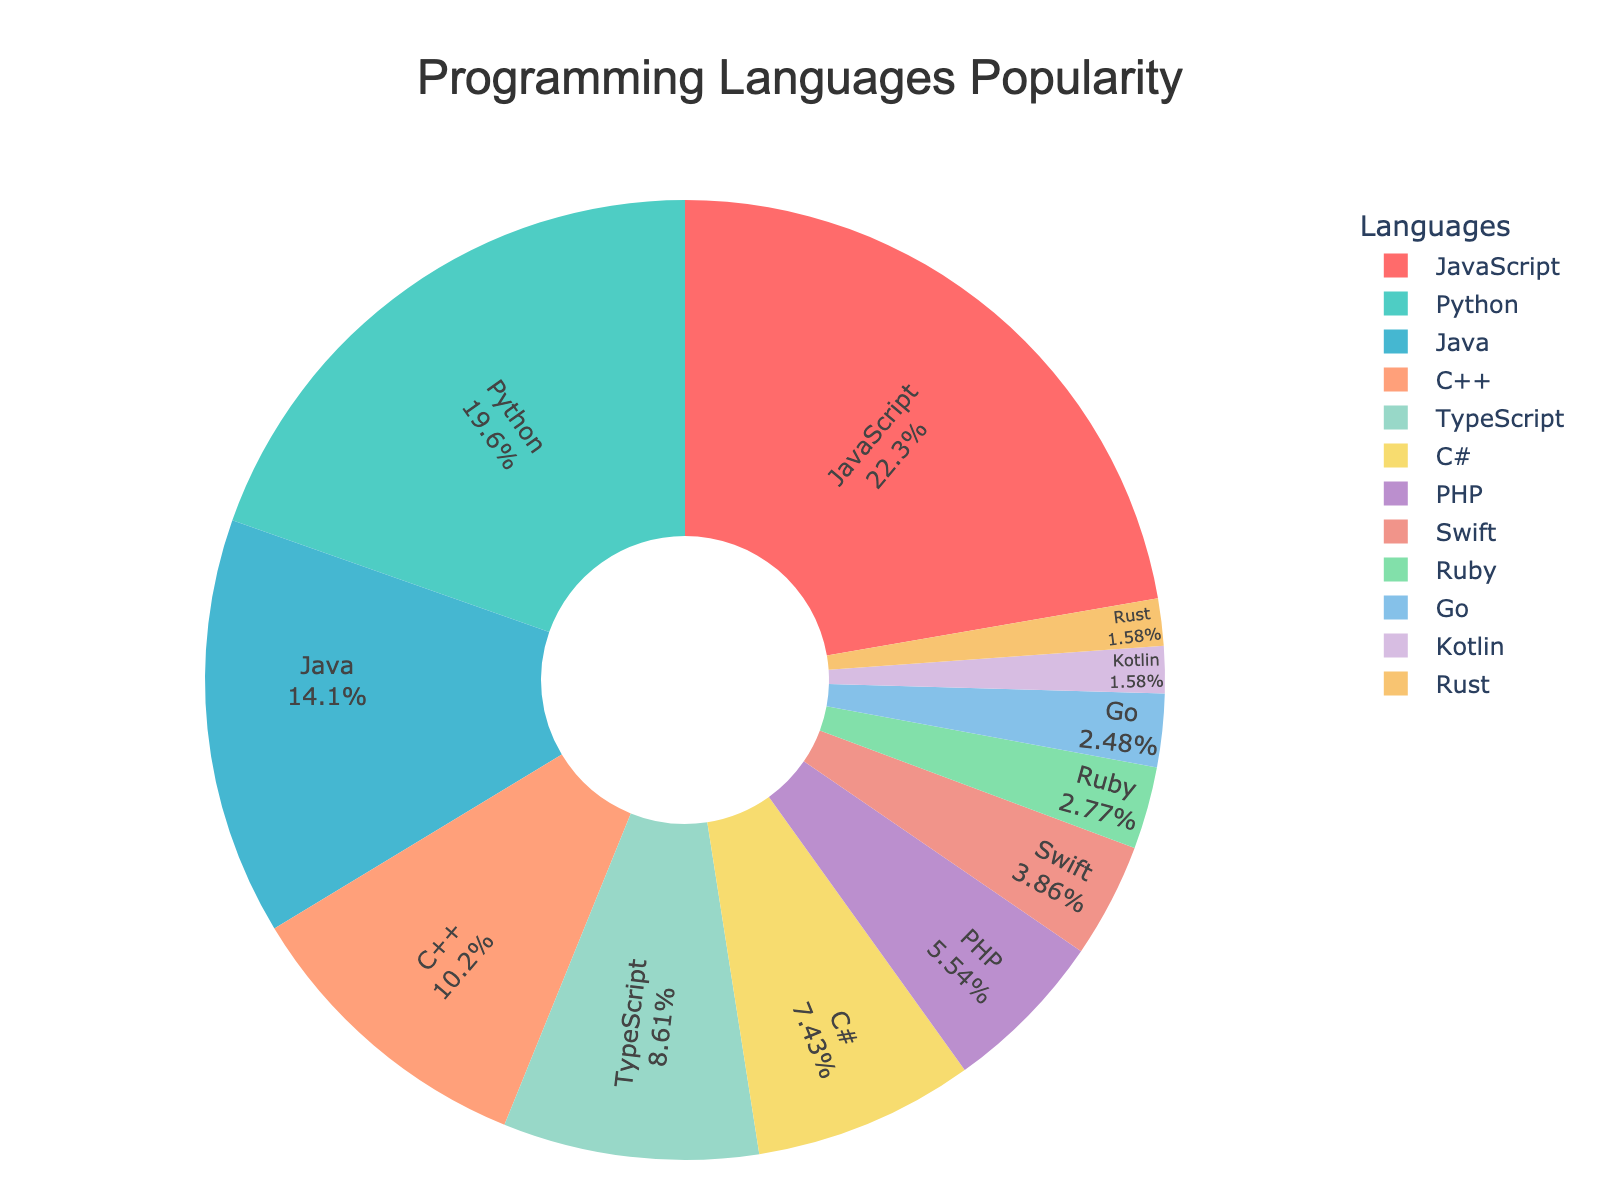What percentage of developers use JavaScript? Look at the segment labeled JavaScript and read the corresponding percentage.
Answer: 22.5% Which programming language is the second most popular? Identify and compare the percentages of the segments. The second highest value is 19.8%, which corresponds to Python.
Answer: Python How much more popular is JavaScript compared to PHP? Find the percentages for JavaScript (22.5%) and PHP (5.6%), then calculate the difference: 22.5% - 5.6% = 16.9%.
Answer: 16.9% What is the total popularity percentage of TypeScript and Swift combined? Find the percentages for TypeScript (8.7%) and Swift (3.9%), then sum them: 8.7% + 3.9% = 12.6%.
Answer: 12.6% Which language takes up the smallest segment in the pie chart? Find the segment with the smallest percentage, which is Kotlin (1.6%) and Rust (1.6%). Since they have the same percentage, they both take up the smallest segment.
Answer: Kotlin and Rust Are there more developers using C++ or C#? Compare the percentages of C++ (10.3%) and C# (7.5%). Since 10.3% > 7.5%, more developers use C++.
Answer: C++ What is the total percentage of developers using JavaScript, Python, and Java combined? Find the percentages for JavaScript (22.5%), Python (19.8%), and Java (14.2%), then sum them: 22.5% + 19.8% + 14.2% = 56.5%.
Answer: 56.5% Which segment is larger, PHP or Ruby? Compare the segments for PHP (5.6%) and Ruby (2.8%). Since 5.6% > 2.8%, the PHP segment is larger.
Answer: PHP How much more popular is Python than Go? Find the percentages for Python (19.8%) and Go (2.5%), then calculate the difference: 19.8% - 2.5% = 17.3%.
Answer: 17.3% What percentage of developers do not use JavaScript, Python, or Java? Find the total percentage for JavaScript (22.5%), Python (19.8%), and Java (14.2%), then subtract from 100%: 100% - (22.5% + 19.8% + 14.2%) = 43.5%.
Answer: 43.5% 